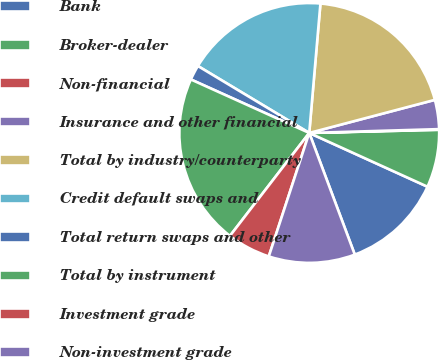<chart> <loc_0><loc_0><loc_500><loc_500><pie_chart><fcel>Bank<fcel>Broker-dealer<fcel>Non-financial<fcel>Insurance and other financial<fcel>Total by industry/counterparty<fcel>Credit default swaps and<fcel>Total return swaps and other<fcel>Total by instrument<fcel>Investment grade<fcel>Non-investment grade<nl><fcel>12.51%<fcel>7.18%<fcel>0.08%<fcel>3.63%<fcel>19.53%<fcel>17.76%<fcel>1.86%<fcel>21.31%<fcel>5.41%<fcel>10.74%<nl></chart> 